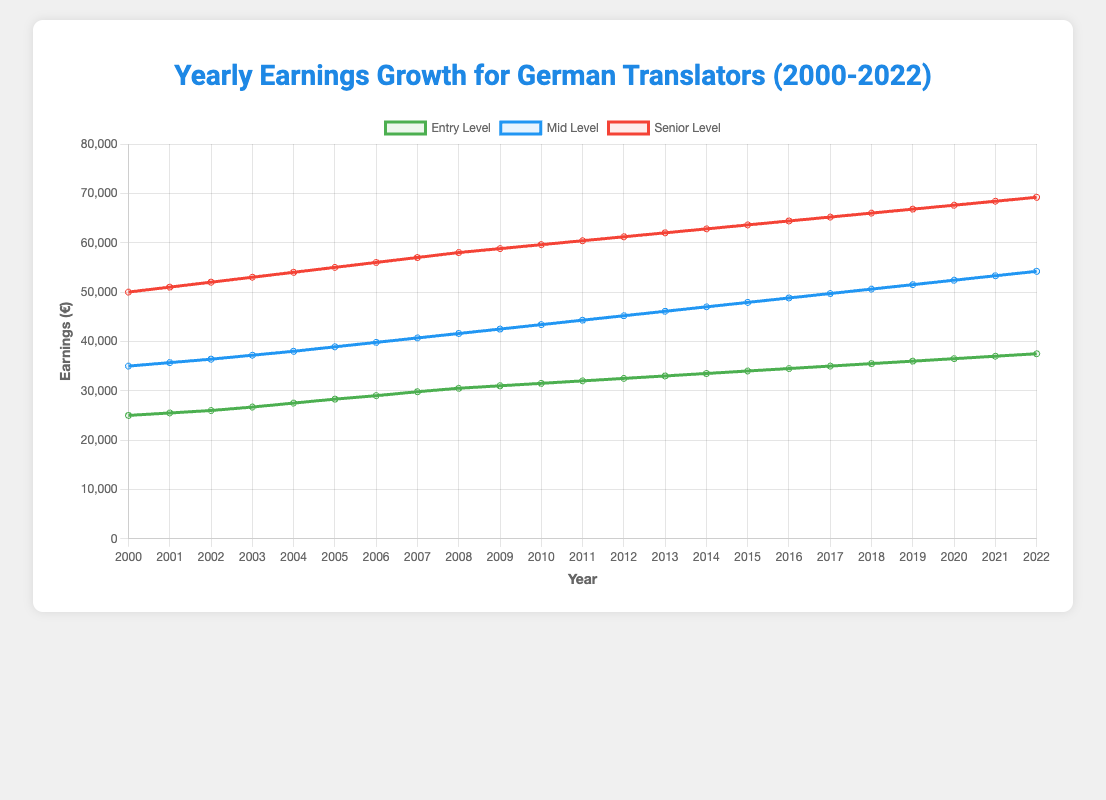What is the earnings difference between entry-level and senior-level translators in 2010? In 2010, the earnings for entry-level translators were €31,500 and for senior-level translators were €59,600. The difference is €59,600 - €31,500.
Answer: €28,100 Which experience level showed the highest increase in yearly earnings between 2000 and 2022? To find the highest increase, we subtract the earnings in 2000 from those in 2022 for each experience level. Entry-level increase: €37,500 - €25,000 = €12,500. Mid-level increase: €54,200 - €35,000 = €19,200. Senior-level increase: €69,200 - €50,000 = €19,200. Both mid-level and senior-level showed the highest increase, which is the same.
Answer: Mid-level and Senior-level What is the trend in earnings for entry-level translators from 2000 to 2022? The earnings for entry-level translators show a consistent increase every year from €25,000 in 2000 to €37,500 in 2022. This indicates a steady growth trend.
Answer: Steady growth In which year did mid-level translators first surpass €50,000 in earnings? Looking at the earnings of mid-level translators over the years, we see they surpassed €50,000 in 2018.
Answer: 2018 By how much did the earnings for senior-level translators grow on average per year from 2000 to 2022? First, calculate the total increase: €69,200 - €50,000 = €19,200. Next, divide the increase by the number of years: €19,200 / 22 ≈ €872.73.
Answer: €872.73 How do the earnings of mid-level translators in 2015 compare to those of senior-level translators in 2005? The earnings for mid-level translators in 2015 were €47,900, while senior-level translators in 2005 earned €55,000. The earnings of senior-level translators in 2005 were higher.
Answer: Senior-level in 2005 are higher What was the percentage increase in earnings for entry-level translators from 2000 to 2010? Calculate the increase: €31,500 - €25,000 = €6,500. Then, find the percentage increase: (€6,500 / €25,000) * 100 ≈ 26%.
Answer: 26% Which year saw the smallest increase in earnings for mid-level translators compared to the previous year? By comparing year-over-year increases for mid-level, the smallest increase is from 2019 to 2020, which is €52,400 - €51,500 = €900.
Answer: 2020 For which experience level is the slope of the earnings trend line the steepest? The steepest slope can be analyzed by looking at the consistent linear increase in earnings. Both mid-level and senior-level show the highest total increase, hence the trend lines for both have the steepest slope.
Answer: Mid-level and Senior-level What is the visual difference in the growth patterns of earnings for senior-level versus entry-level translators from 2000 to 2022? The growth pattern for senior-level translators shows a steeper and higher increase, represented by the red line in the plot, compared to the entry-level which is represented by the green line. The senior-level line is visually higher and separates more distinctly.
Answer: The senior-level line is steeper and higher 